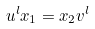Convert formula to latex. <formula><loc_0><loc_0><loc_500><loc_500>u ^ { l } x _ { 1 } = x _ { 2 } v ^ { l }</formula> 